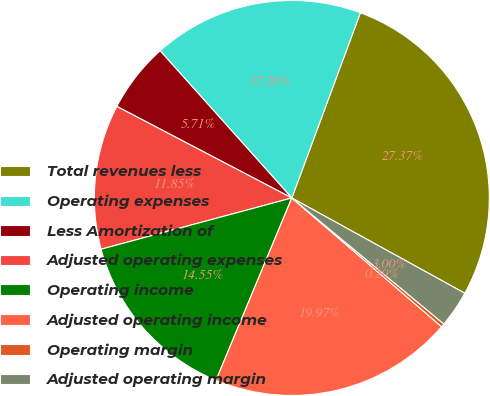Convert chart to OTSL. <chart><loc_0><loc_0><loc_500><loc_500><pie_chart><fcel>Total revenues less<fcel>Operating expenses<fcel>Less Amortization of<fcel>Adjusted operating expenses<fcel>Operating income<fcel>Adjusted operating income<fcel>Operating margin<fcel>Adjusted operating margin<nl><fcel>27.37%<fcel>17.26%<fcel>5.71%<fcel>11.85%<fcel>14.55%<fcel>19.97%<fcel>0.29%<fcel>3.0%<nl></chart> 